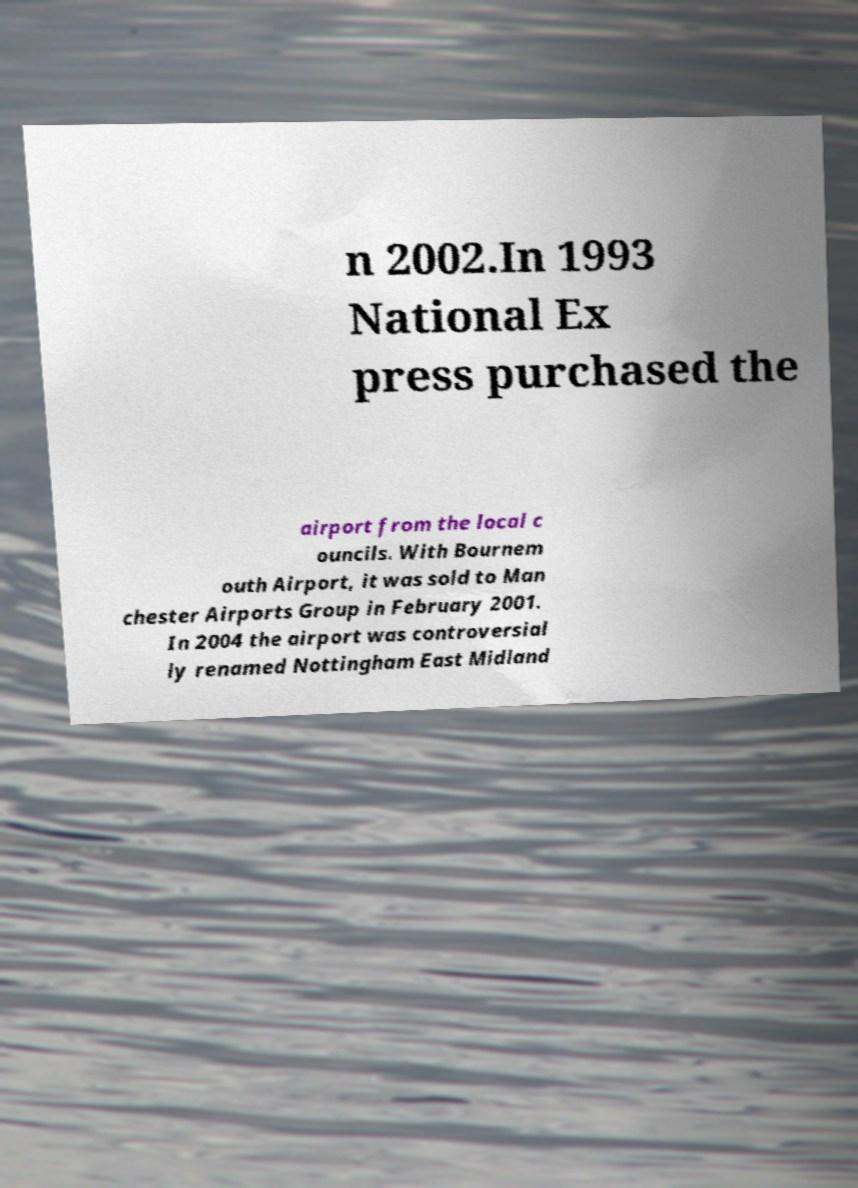For documentation purposes, I need the text within this image transcribed. Could you provide that? n 2002.In 1993 National Ex press purchased the airport from the local c ouncils. With Bournem outh Airport, it was sold to Man chester Airports Group in February 2001. In 2004 the airport was controversial ly renamed Nottingham East Midland 